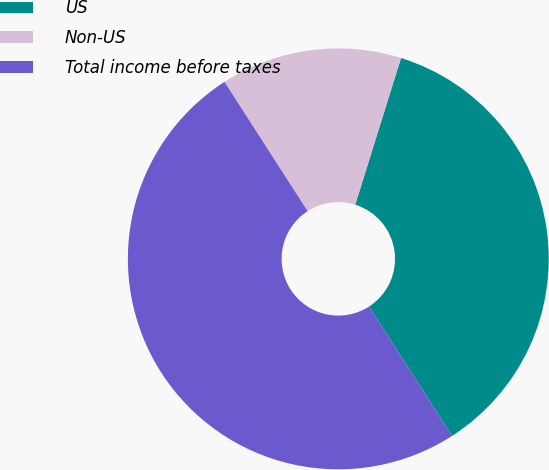Convert chart to OTSL. <chart><loc_0><loc_0><loc_500><loc_500><pie_chart><fcel>US<fcel>Non-US<fcel>Total income before taxes<nl><fcel>36.09%<fcel>13.91%<fcel>50.0%<nl></chart> 